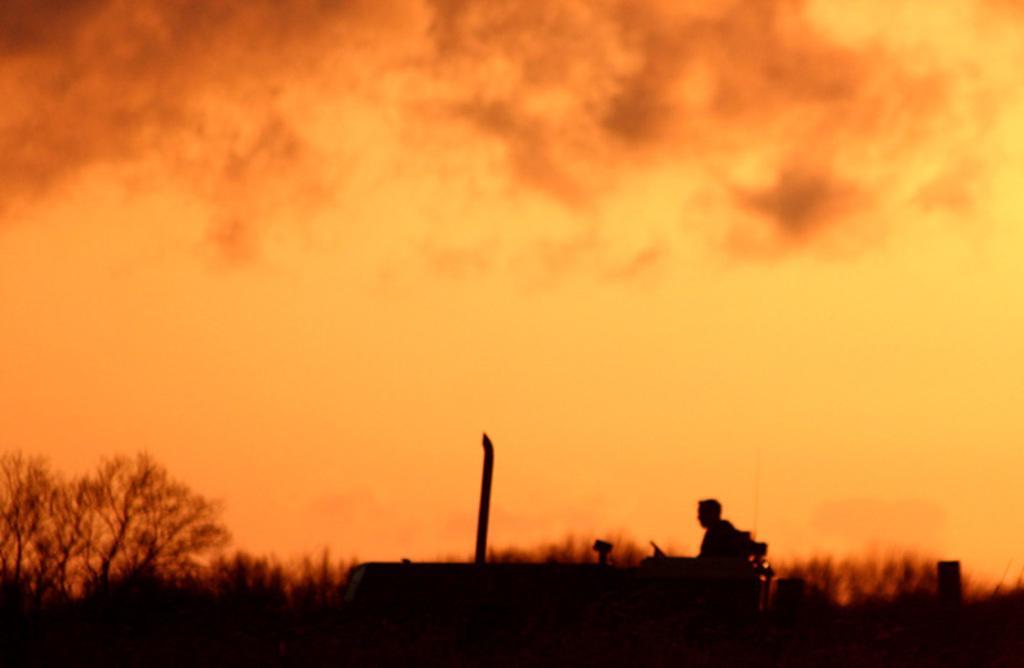How would you summarize this image in a sentence or two? There is a person sitting on the seat and driving the tractor on the road. In the background, there are trees and there are clouds in the sky. 